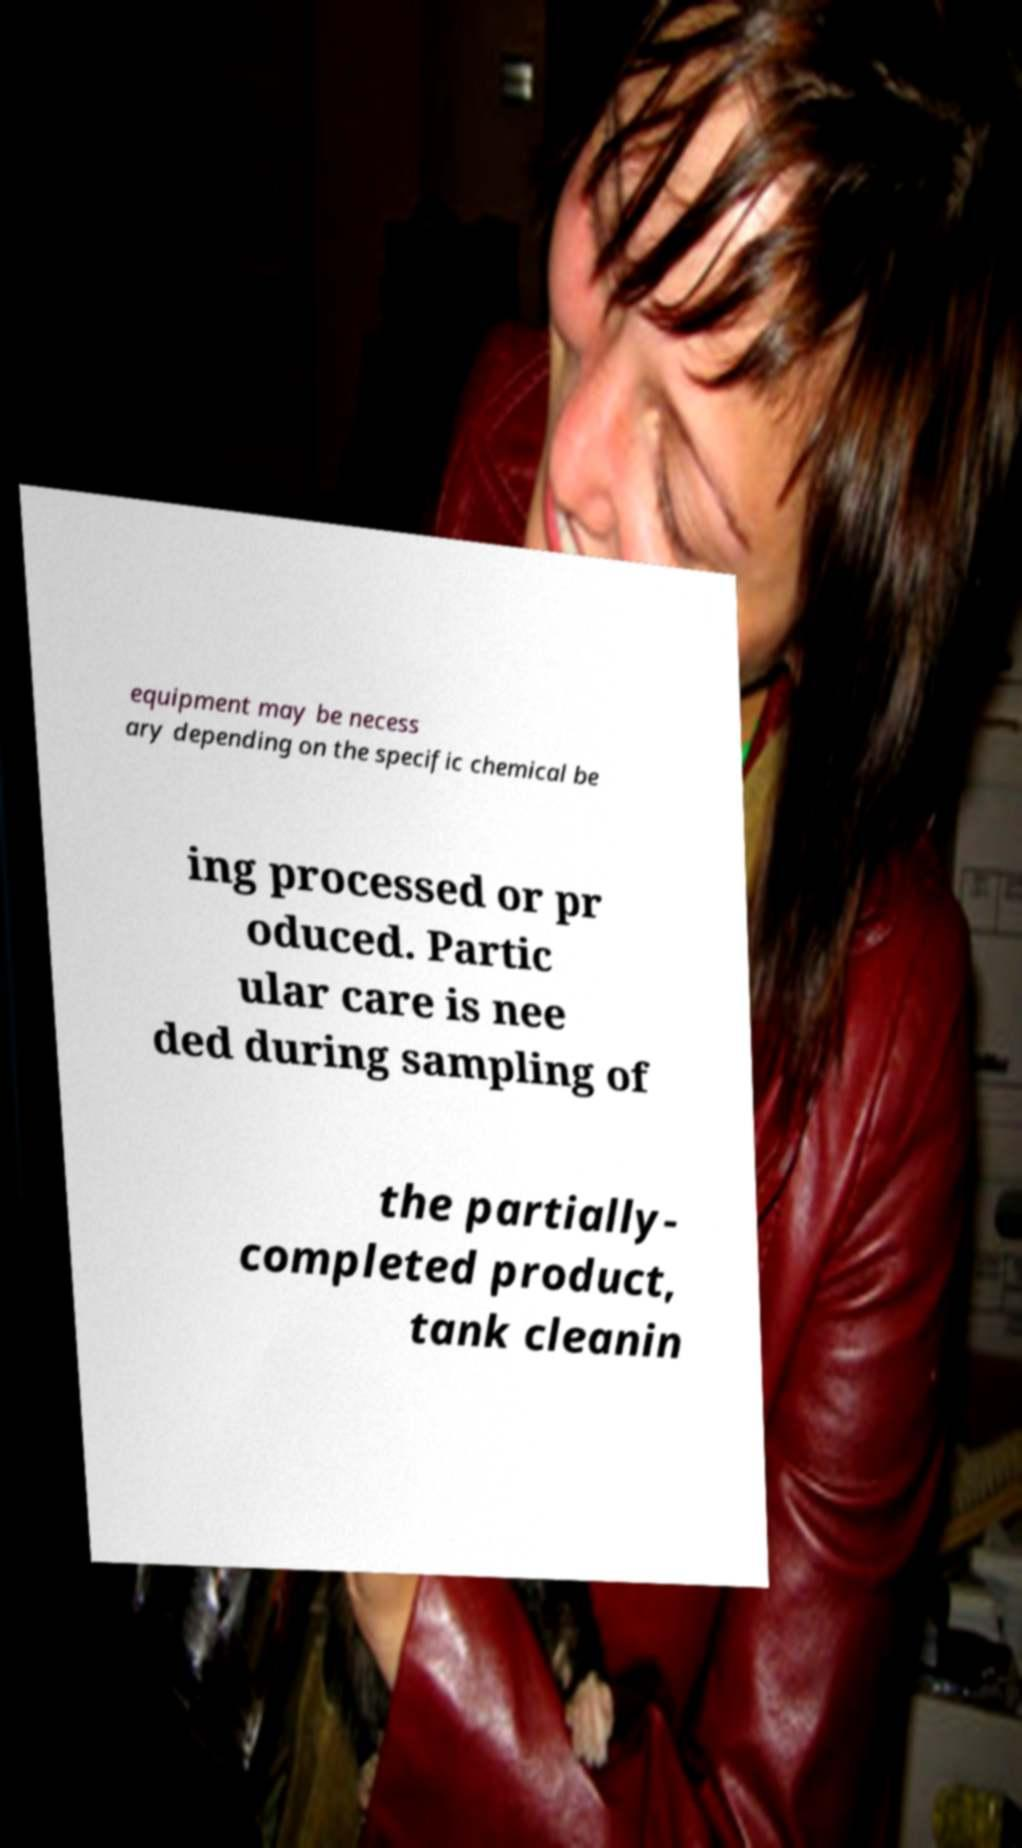Please identify and transcribe the text found in this image. equipment may be necess ary depending on the specific chemical be ing processed or pr oduced. Partic ular care is nee ded during sampling of the partially- completed product, tank cleanin 